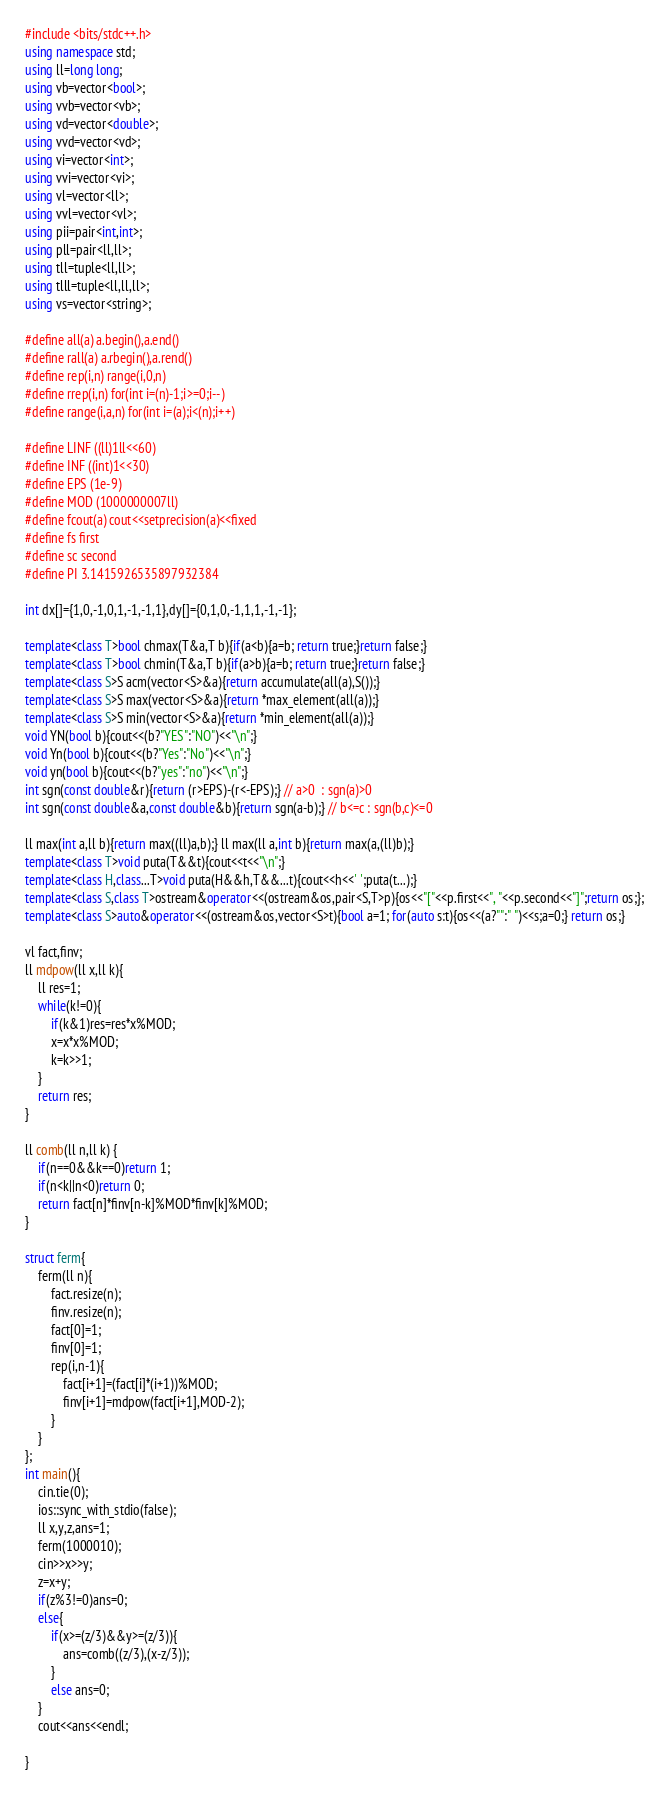<code> <loc_0><loc_0><loc_500><loc_500><_C++_>#include <bits/stdc++.h>
using namespace std;
using ll=long long;
using vb=vector<bool>;
using vvb=vector<vb>;
using vd=vector<double>;
using vvd=vector<vd>;
using vi=vector<int>;
using vvi=vector<vi>;
using vl=vector<ll>;
using vvl=vector<vl>;
using pii=pair<int,int>;
using pll=pair<ll,ll>;
using tll=tuple<ll,ll>;
using tlll=tuple<ll,ll,ll>;
using vs=vector<string>;

#define all(a) a.begin(),a.end()
#define rall(a) a.rbegin(),a.rend()
#define rep(i,n) range(i,0,n)
#define rrep(i,n) for(int i=(n)-1;i>=0;i--)
#define range(i,a,n) for(int i=(a);i<(n);i++)

#define LINF ((ll)1ll<<60)
#define INF ((int)1<<30)
#define EPS (1e-9)
#define MOD (1000000007ll)
#define fcout(a) cout<<setprecision(a)<<fixed
#define fs first
#define sc second
#define PI 3.1415926535897932384

int dx[]={1,0,-1,0,1,-1,-1,1},dy[]={0,1,0,-1,1,1,-1,-1};

template<class T>bool chmax(T&a,T b){if(a<b){a=b; return true;}return false;}
template<class T>bool chmin(T&a,T b){if(a>b){a=b; return true;}return false;}
template<class S>S acm(vector<S>&a){return accumulate(all(a),S());}
template<class S>S max(vector<S>&a){return *max_element(all(a));}
template<class S>S min(vector<S>&a){return *min_element(all(a));}
void YN(bool b){cout<<(b?"YES":"NO")<<"\n";}
void Yn(bool b){cout<<(b?"Yes":"No")<<"\n";}
void yn(bool b){cout<<(b?"yes":"no")<<"\n";}
int sgn(const double&r){return (r>EPS)-(r<-EPS);} // a>0  : sgn(a)>0
int sgn(const double&a,const double&b){return sgn(a-b);} // b<=c : sgn(b,c)<=0

ll max(int a,ll b){return max((ll)a,b);} ll max(ll a,int b){return max(a,(ll)b);}
template<class T>void puta(T&&t){cout<<t<<"\n";}
template<class H,class...T>void puta(H&&h,T&&...t){cout<<h<<' ';puta(t...);}
template<class S,class T>ostream&operator<<(ostream&os,pair<S,T>p){os<<"["<<p.first<<", "<<p.second<<"]";return os;};
template<class S>auto&operator<<(ostream&os,vector<S>t){bool a=1; for(auto s:t){os<<(a?"":" ")<<s;a=0;} return os;}

vl fact,finv;
ll mdpow(ll x,ll k){
	ll res=1;
	while(k!=0){
		if(k&1)res=res*x%MOD;
		x=x*x%MOD;
		k=k>>1;
	}
	return res;
}

ll comb(ll n,ll k) {
	if(n==0&&k==0)return 1;
	if(n<k||n<0)return 0;
	return fact[n]*finv[n-k]%MOD*finv[k]%MOD;
}

struct ferm{
	ferm(ll n){
		fact.resize(n);
		finv.resize(n);
		fact[0]=1;
		finv[0]=1;
		rep(i,n-1){
			fact[i+1]=(fact[i]*(i+1))%MOD;
			finv[i+1]=mdpow(fact[i+1],MOD-2);
		}
	}
};
int main(){
	cin.tie(0);
	ios::sync_with_stdio(false);
	ll x,y,z,ans=1;
	ferm(1000010);
	cin>>x>>y;
	z=x+y;
	if(z%3!=0)ans=0;
	else{
		if(x>=(z/3)&&y>=(z/3)){
			ans=comb((z/3),(x-z/3));
		}
		else ans=0;
	}
	cout<<ans<<endl;

}
</code> 